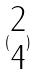Convert formula to latex. <formula><loc_0><loc_0><loc_500><loc_500>( \begin{matrix} 2 \\ 4 \end{matrix} )</formula> 